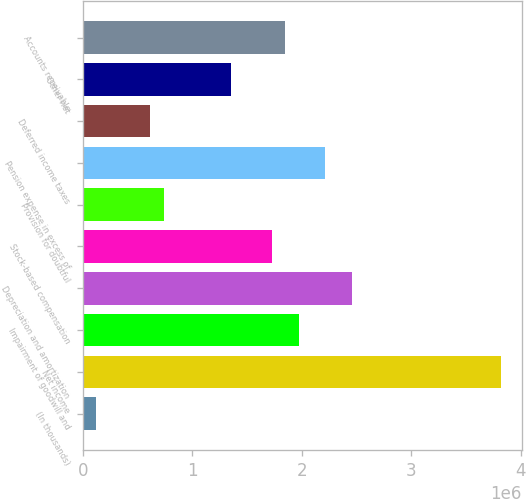<chart> <loc_0><loc_0><loc_500><loc_500><bar_chart><fcel>(In thousands)<fcel>Net income<fcel>Impairment of goodwill and<fcel>Depreciation and amortization<fcel>Stock-based compensation<fcel>Provision for doubtful<fcel>Pension expense in excess of<fcel>Deferred income taxes<fcel>Other net<fcel>Accounts receivable<nl><fcel>123871<fcel>3.81628e+06<fcel>1.97007e+06<fcel>2.4624e+06<fcel>1.72391e+06<fcel>739272<fcel>2.21623e+06<fcel>616192<fcel>1.35467e+06<fcel>1.84699e+06<nl></chart> 